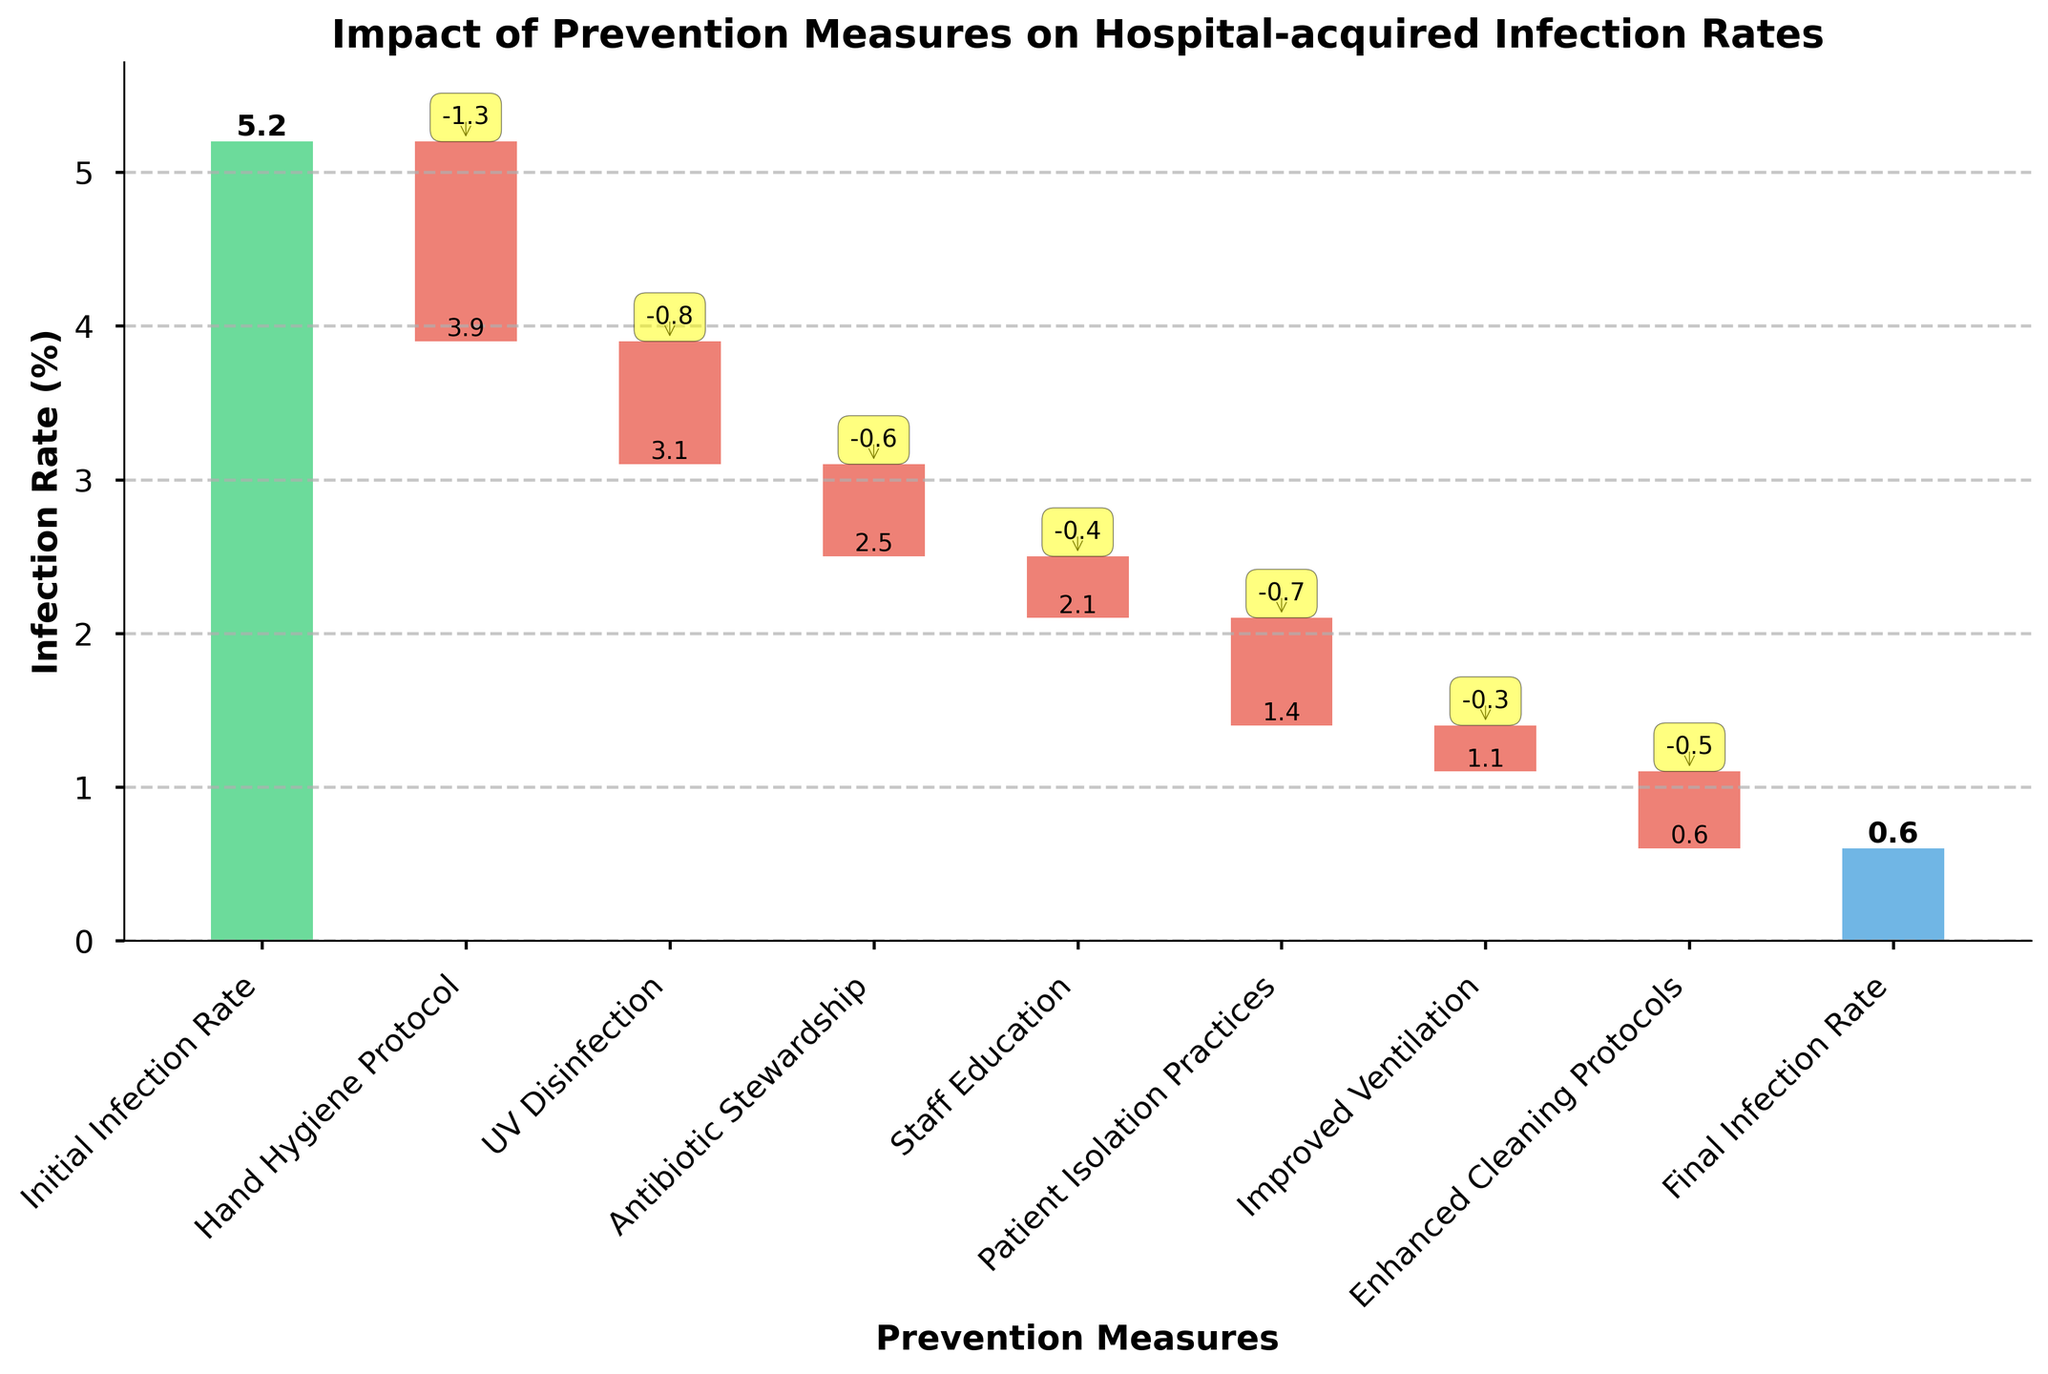What's the title of the chart? The title is centered at the top of the chart and summarizes the visualization.
Answer: Impact of Prevention Measures on Hospital-acquired Infection Rates What is the initial infection rate? The initial infection rate is the starting value in the waterfall chart, represented by the first bar on the left.
Answer: 5.2% What is the final infection rate? The final infection rate is represented by the last bar on the right of the waterfall chart.
Answer: 0.6% How much did the hand hygiene protocol reduce the infection rate? The reduction due to the hand hygiene protocol is shown as a negative value on the bar labeled "Hand Hygiene Protocol."
Answer: -1.3% Which prevention measure had the smallest impact on the infection rate? By examining the height of the bars, the measure with the smallest impact is "Improved Ventilation."
Answer: -0.3% What is the cumulative impact of UV Disinfection and Antibiotic Stewardship on the infection rate? To find the cumulative impact, add the values for UV Disinfection and Antibiotic Stewardship: -0.8 + -0.6.
Answer: -1.4% What is the difference between the impacts of Hand Hygiene Protocol and Patient Isolation Practices? Subtract the impact of Patient Isolation Practices from the impact of the Hand Hygiene Protocol: -1.3 - (-0.7).
Answer: -0.6% How many prevention measures are shown in the chart? Count the number of bars between the initial and the final rate.
Answer: 7 Which prevention measure follows Staff Education in the sequence? In the order of the bars, the measure after "Staff Education" is "Patient Isolation Practices."
Answer: Patient Isolation Practices If we sum the impacts of all the prevention measures, what is the total reduction in the infection rate? Sum up all the negative values of the prevention measures: -1.3 + -0.8 + -0.6 + -0.4 + -0.7 + -0.3 + -0.5.
Answer: -4.6% 